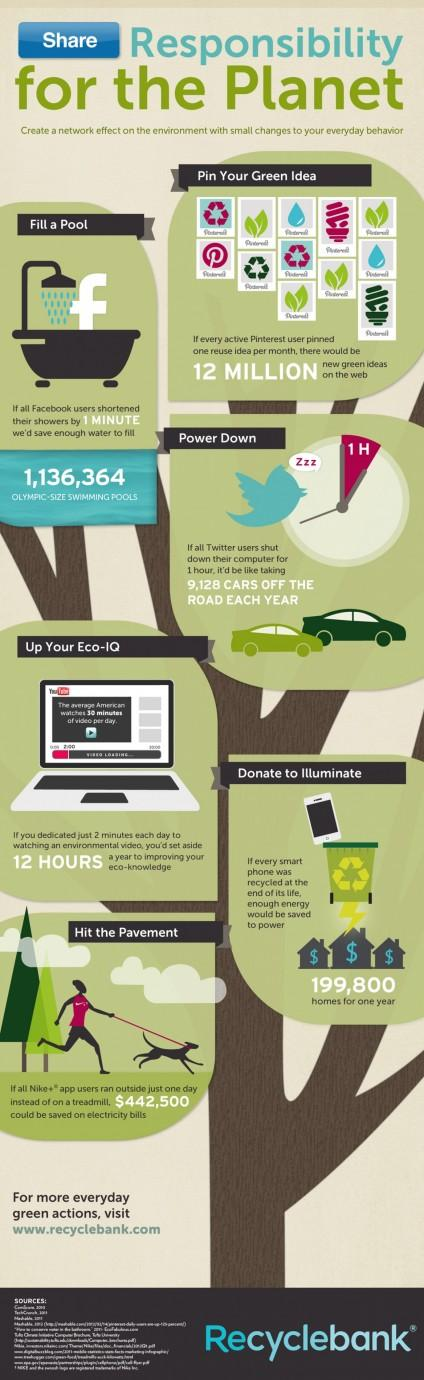Give some essential details in this illustration. Out of the six small changes mentioned, the last two are 'donate to illuminate' and 'hit the pavement'. If all Nike app users refrained from using the treadmill for one day, it is estimated that the amount of money saved on electricity bills would be approximately $442,500. To reduce the number of cars on the road by 9128, Twitter users should power down their computers for 60 minutes. If every Pinterest user pinned a single reuse idea per month, there would be 12 million reuse ideas on the web. If all Facebook users shortened their showers by 1 minute, it would result in enough water to fill approximately 1,136,364 Olympic-size swimming pools. 